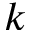Convert formula to latex. <formula><loc_0><loc_0><loc_500><loc_500>k</formula> 